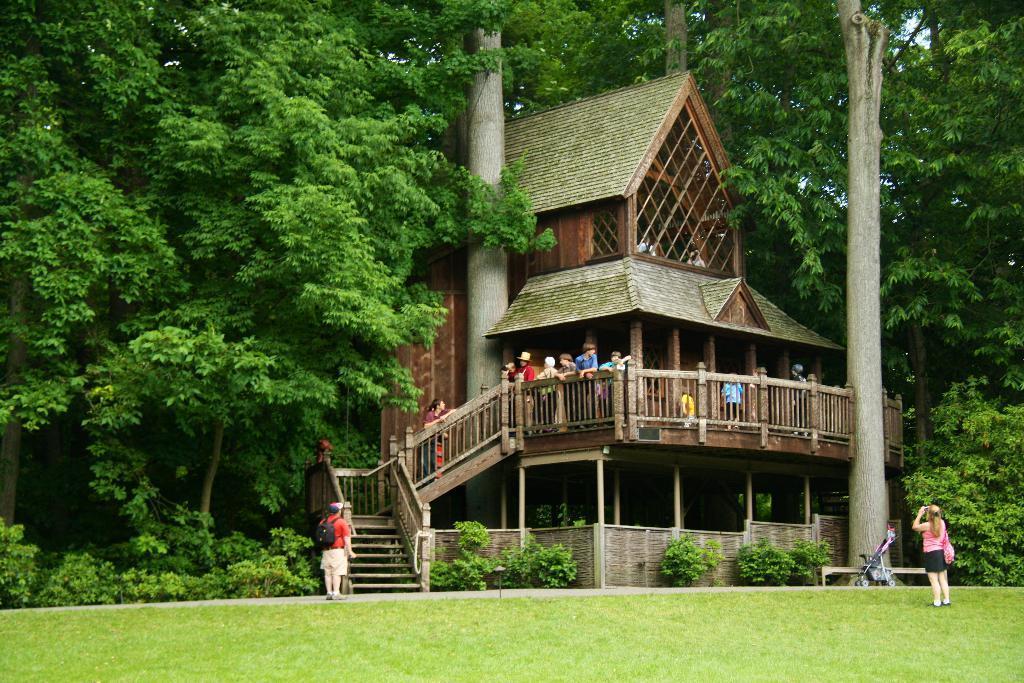How would you summarize this image in a sentence or two? In this picture we can observe a wooden house. There are some people standing here. We can observe a railing. On the right side there is a woman standing, taking a photograph. There are trees. We can observe some grass on the ground. 